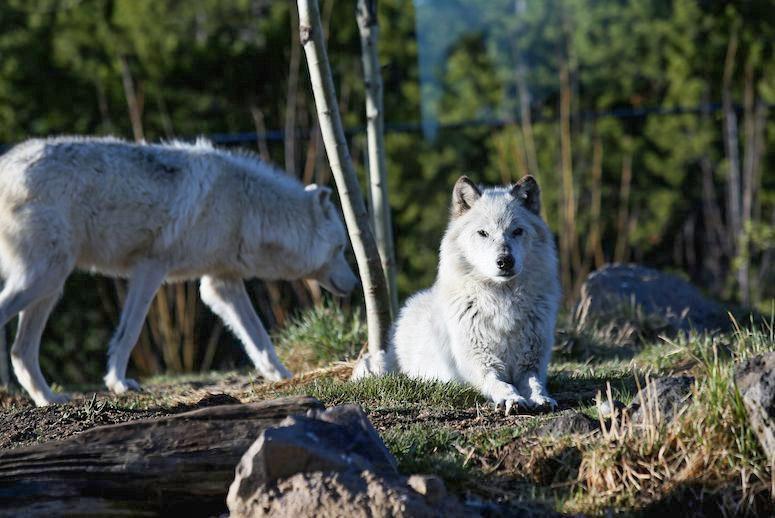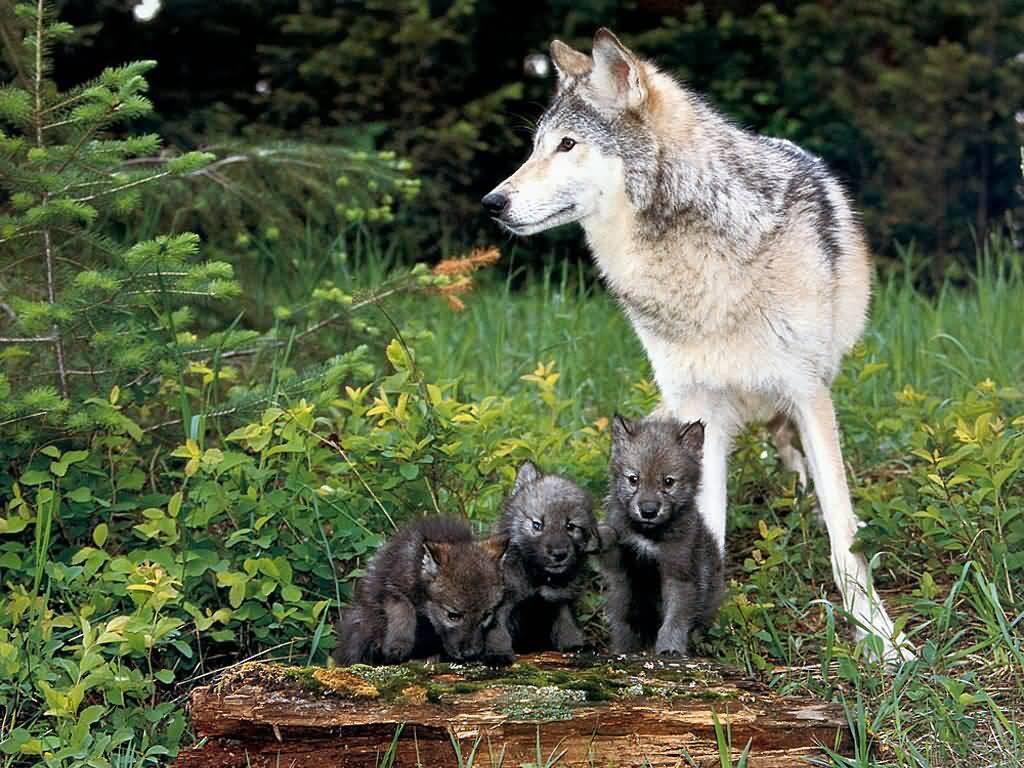The first image is the image on the left, the second image is the image on the right. Analyze the images presented: Is the assertion "The right image features an adult wolf with left-turned face next to multiple pups." valid? Answer yes or no. Yes. The first image is the image on the left, the second image is the image on the right. Examine the images to the left and right. Is the description "There is a single wolf with its face partially covered by foliage in one of the images." accurate? Answer yes or no. No. 